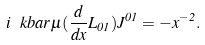<formula> <loc_0><loc_0><loc_500><loc_500>i \ k b a r \mu ( \frac { d } { d x } L _ { 0 1 } ) J ^ { 0 1 } = - x ^ { - 2 } .</formula> 